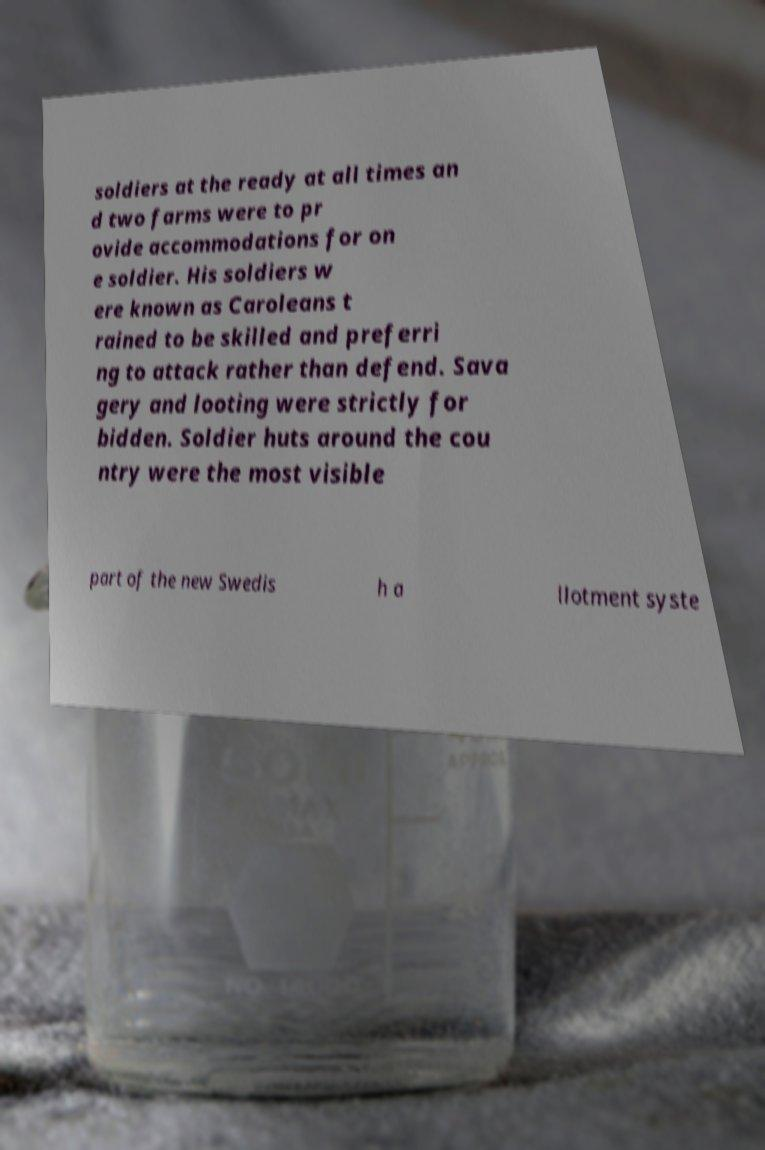Can you read and provide the text displayed in the image?This photo seems to have some interesting text. Can you extract and type it out for me? soldiers at the ready at all times an d two farms were to pr ovide accommodations for on e soldier. His soldiers w ere known as Caroleans t rained to be skilled and preferri ng to attack rather than defend. Sava gery and looting were strictly for bidden. Soldier huts around the cou ntry were the most visible part of the new Swedis h a llotment syste 